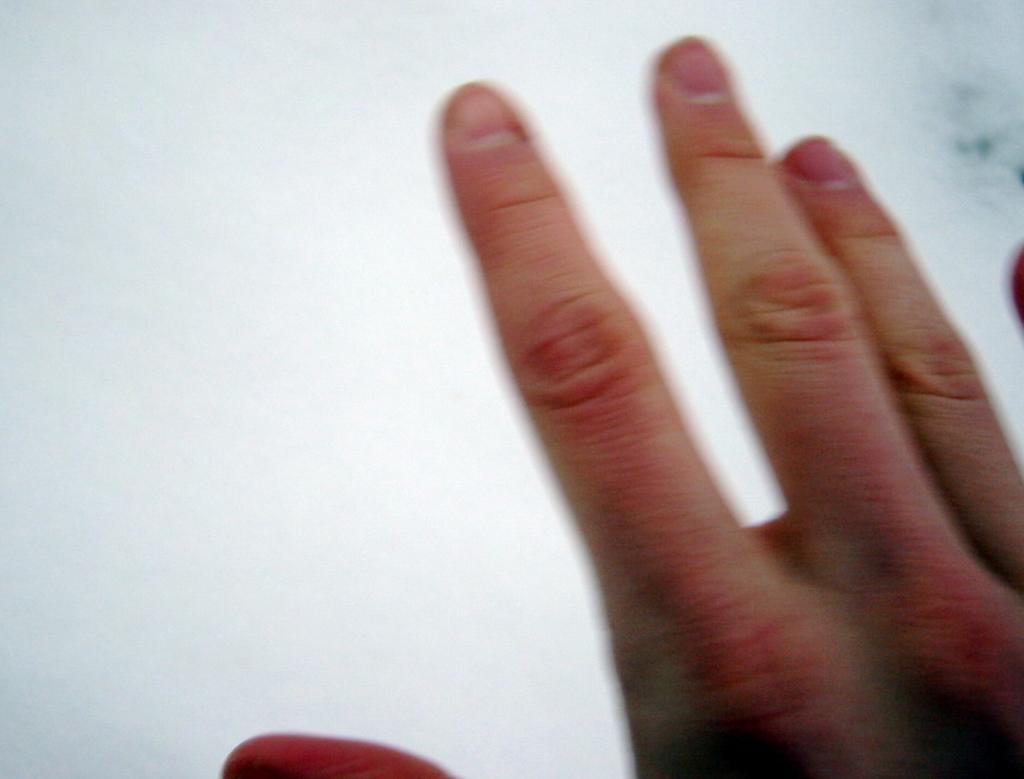In one or two sentences, can you explain what this image depicts? In this picture we can see a person's hand. Behind the hand, there is the white background. 